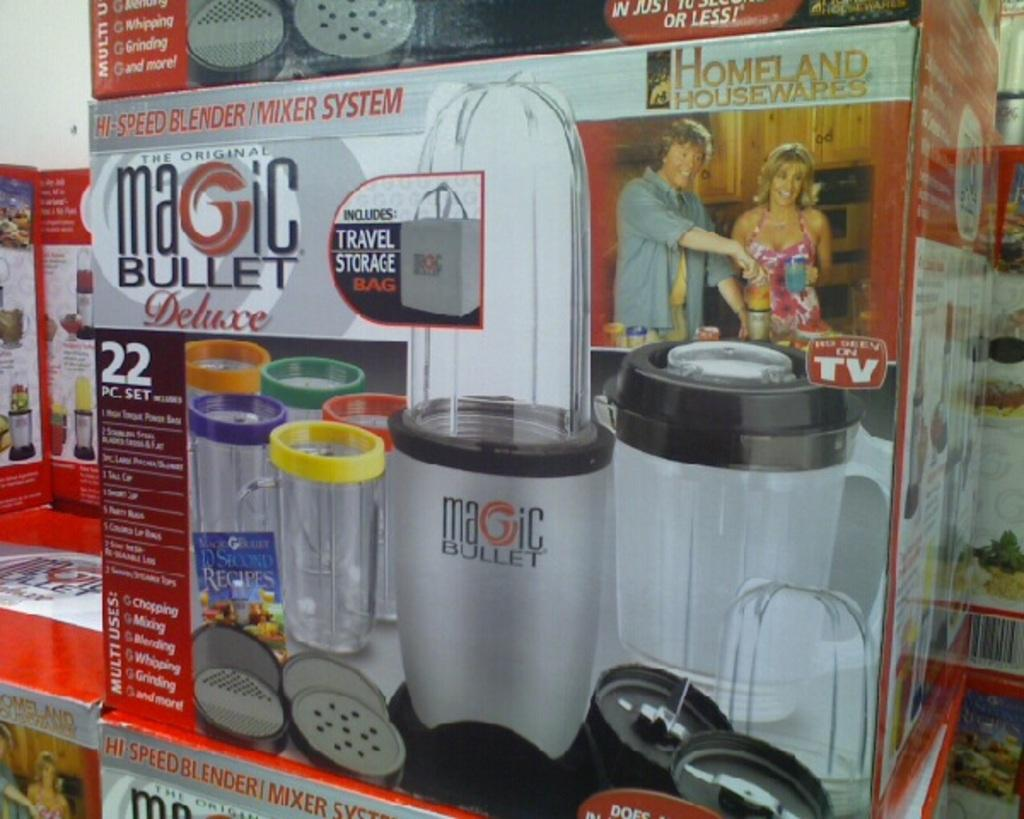<image>
Offer a succinct explanation of the picture presented. a magic bullet advertisement on a box in a room 